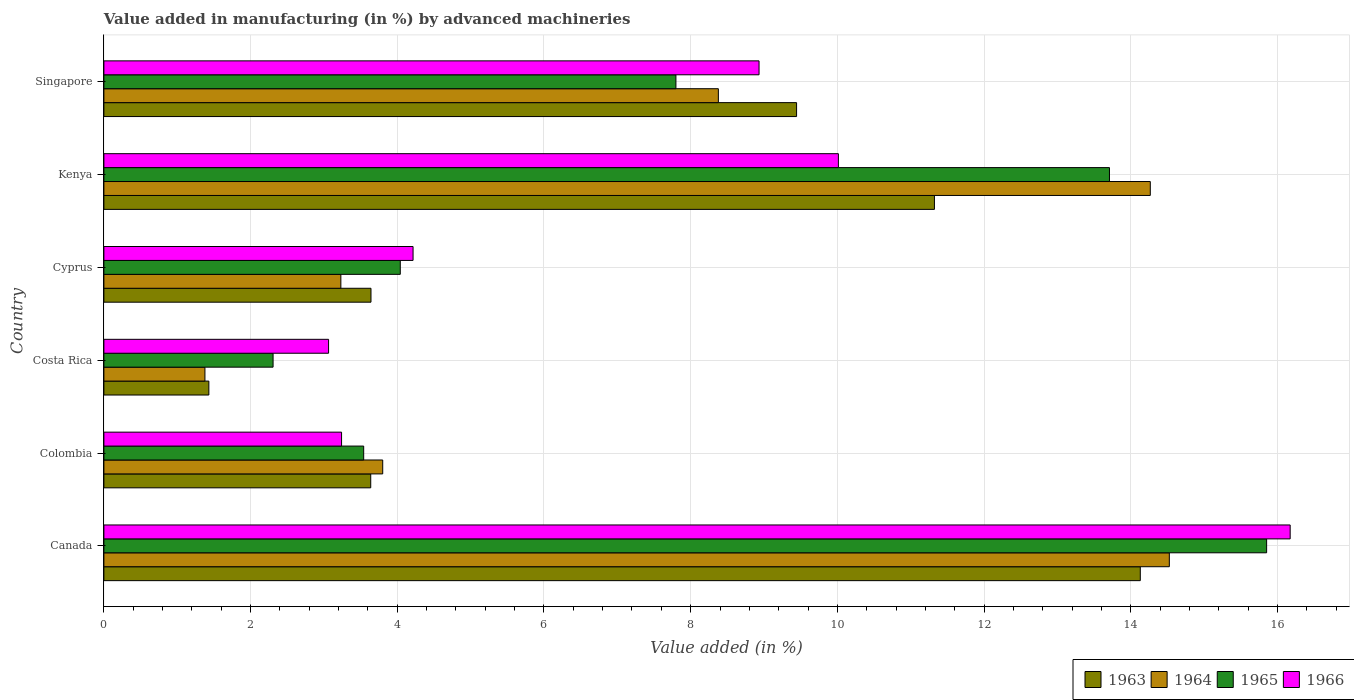How many different coloured bars are there?
Provide a succinct answer. 4. What is the percentage of value added in manufacturing by advanced machineries in 1964 in Kenya?
Offer a very short reply. 14.27. Across all countries, what is the maximum percentage of value added in manufacturing by advanced machineries in 1966?
Make the answer very short. 16.17. Across all countries, what is the minimum percentage of value added in manufacturing by advanced machineries in 1966?
Offer a very short reply. 3.06. In which country was the percentage of value added in manufacturing by advanced machineries in 1963 maximum?
Give a very brief answer. Canada. What is the total percentage of value added in manufacturing by advanced machineries in 1966 in the graph?
Your answer should be very brief. 45.64. What is the difference between the percentage of value added in manufacturing by advanced machineries in 1966 in Canada and that in Cyprus?
Give a very brief answer. 11.96. What is the difference between the percentage of value added in manufacturing by advanced machineries in 1964 in Kenya and the percentage of value added in manufacturing by advanced machineries in 1966 in Singapore?
Offer a very short reply. 5.33. What is the average percentage of value added in manufacturing by advanced machineries in 1964 per country?
Provide a short and direct response. 7.6. What is the difference between the percentage of value added in manufacturing by advanced machineries in 1964 and percentage of value added in manufacturing by advanced machineries in 1963 in Cyprus?
Provide a succinct answer. -0.41. In how many countries, is the percentage of value added in manufacturing by advanced machineries in 1965 greater than 8.4 %?
Make the answer very short. 2. What is the ratio of the percentage of value added in manufacturing by advanced machineries in 1964 in Colombia to that in Kenya?
Your answer should be compact. 0.27. Is the percentage of value added in manufacturing by advanced machineries in 1963 in Canada less than that in Kenya?
Offer a very short reply. No. Is the difference between the percentage of value added in manufacturing by advanced machineries in 1964 in Colombia and Singapore greater than the difference between the percentage of value added in manufacturing by advanced machineries in 1963 in Colombia and Singapore?
Your response must be concise. Yes. What is the difference between the highest and the second highest percentage of value added in manufacturing by advanced machineries in 1963?
Your answer should be compact. 2.81. What is the difference between the highest and the lowest percentage of value added in manufacturing by advanced machineries in 1965?
Your answer should be very brief. 13.55. In how many countries, is the percentage of value added in manufacturing by advanced machineries in 1963 greater than the average percentage of value added in manufacturing by advanced machineries in 1963 taken over all countries?
Your response must be concise. 3. Is it the case that in every country, the sum of the percentage of value added in manufacturing by advanced machineries in 1964 and percentage of value added in manufacturing by advanced machineries in 1966 is greater than the sum of percentage of value added in manufacturing by advanced machineries in 1963 and percentage of value added in manufacturing by advanced machineries in 1965?
Offer a very short reply. No. What does the 4th bar from the bottom in Canada represents?
Provide a short and direct response. 1966. Are all the bars in the graph horizontal?
Offer a very short reply. Yes. How many countries are there in the graph?
Keep it short and to the point. 6. What is the difference between two consecutive major ticks on the X-axis?
Your response must be concise. 2. Does the graph contain any zero values?
Ensure brevity in your answer.  No. Where does the legend appear in the graph?
Keep it short and to the point. Bottom right. How are the legend labels stacked?
Offer a terse response. Horizontal. What is the title of the graph?
Ensure brevity in your answer.  Value added in manufacturing (in %) by advanced machineries. What is the label or title of the X-axis?
Keep it short and to the point. Value added (in %). What is the label or title of the Y-axis?
Your answer should be very brief. Country. What is the Value added (in %) in 1963 in Canada?
Offer a terse response. 14.13. What is the Value added (in %) in 1964 in Canada?
Offer a very short reply. 14.53. What is the Value added (in %) in 1965 in Canada?
Your response must be concise. 15.85. What is the Value added (in %) of 1966 in Canada?
Offer a very short reply. 16.17. What is the Value added (in %) in 1963 in Colombia?
Make the answer very short. 3.64. What is the Value added (in %) in 1964 in Colombia?
Your answer should be compact. 3.8. What is the Value added (in %) of 1965 in Colombia?
Provide a succinct answer. 3.54. What is the Value added (in %) of 1966 in Colombia?
Provide a succinct answer. 3.24. What is the Value added (in %) in 1963 in Costa Rica?
Provide a succinct answer. 1.43. What is the Value added (in %) in 1964 in Costa Rica?
Provide a succinct answer. 1.38. What is the Value added (in %) of 1965 in Costa Rica?
Make the answer very short. 2.31. What is the Value added (in %) in 1966 in Costa Rica?
Provide a succinct answer. 3.06. What is the Value added (in %) in 1963 in Cyprus?
Your response must be concise. 3.64. What is the Value added (in %) of 1964 in Cyprus?
Offer a terse response. 3.23. What is the Value added (in %) in 1965 in Cyprus?
Offer a terse response. 4.04. What is the Value added (in %) of 1966 in Cyprus?
Keep it short and to the point. 4.22. What is the Value added (in %) in 1963 in Kenya?
Offer a very short reply. 11.32. What is the Value added (in %) of 1964 in Kenya?
Offer a very short reply. 14.27. What is the Value added (in %) in 1965 in Kenya?
Provide a short and direct response. 13.71. What is the Value added (in %) of 1966 in Kenya?
Your response must be concise. 10.01. What is the Value added (in %) of 1963 in Singapore?
Provide a short and direct response. 9.44. What is the Value added (in %) in 1964 in Singapore?
Offer a very short reply. 8.38. What is the Value added (in %) of 1965 in Singapore?
Offer a terse response. 7.8. What is the Value added (in %) in 1966 in Singapore?
Your answer should be very brief. 8.93. Across all countries, what is the maximum Value added (in %) in 1963?
Give a very brief answer. 14.13. Across all countries, what is the maximum Value added (in %) in 1964?
Make the answer very short. 14.53. Across all countries, what is the maximum Value added (in %) in 1965?
Your response must be concise. 15.85. Across all countries, what is the maximum Value added (in %) of 1966?
Your answer should be compact. 16.17. Across all countries, what is the minimum Value added (in %) in 1963?
Your answer should be compact. 1.43. Across all countries, what is the minimum Value added (in %) in 1964?
Offer a terse response. 1.38. Across all countries, what is the minimum Value added (in %) of 1965?
Ensure brevity in your answer.  2.31. Across all countries, what is the minimum Value added (in %) in 1966?
Provide a succinct answer. 3.06. What is the total Value added (in %) of 1963 in the graph?
Offer a terse response. 43.61. What is the total Value added (in %) in 1964 in the graph?
Provide a succinct answer. 45.58. What is the total Value added (in %) of 1965 in the graph?
Offer a terse response. 47.25. What is the total Value added (in %) of 1966 in the graph?
Your response must be concise. 45.64. What is the difference between the Value added (in %) in 1963 in Canada and that in Colombia?
Your answer should be very brief. 10.49. What is the difference between the Value added (in %) in 1964 in Canada and that in Colombia?
Make the answer very short. 10.72. What is the difference between the Value added (in %) of 1965 in Canada and that in Colombia?
Your answer should be compact. 12.31. What is the difference between the Value added (in %) of 1966 in Canada and that in Colombia?
Offer a very short reply. 12.93. What is the difference between the Value added (in %) in 1963 in Canada and that in Costa Rica?
Offer a very short reply. 12.7. What is the difference between the Value added (in %) in 1964 in Canada and that in Costa Rica?
Keep it short and to the point. 13.15. What is the difference between the Value added (in %) of 1965 in Canada and that in Costa Rica?
Give a very brief answer. 13.55. What is the difference between the Value added (in %) of 1966 in Canada and that in Costa Rica?
Give a very brief answer. 13.11. What is the difference between the Value added (in %) in 1963 in Canada and that in Cyprus?
Provide a succinct answer. 10.49. What is the difference between the Value added (in %) of 1964 in Canada and that in Cyprus?
Provide a short and direct response. 11.3. What is the difference between the Value added (in %) of 1965 in Canada and that in Cyprus?
Ensure brevity in your answer.  11.81. What is the difference between the Value added (in %) in 1966 in Canada and that in Cyprus?
Offer a very short reply. 11.96. What is the difference between the Value added (in %) in 1963 in Canada and that in Kenya?
Offer a very short reply. 2.81. What is the difference between the Value added (in %) in 1964 in Canada and that in Kenya?
Your answer should be very brief. 0.26. What is the difference between the Value added (in %) in 1965 in Canada and that in Kenya?
Provide a short and direct response. 2.14. What is the difference between the Value added (in %) in 1966 in Canada and that in Kenya?
Provide a succinct answer. 6.16. What is the difference between the Value added (in %) in 1963 in Canada and that in Singapore?
Keep it short and to the point. 4.69. What is the difference between the Value added (in %) of 1964 in Canada and that in Singapore?
Make the answer very short. 6.15. What is the difference between the Value added (in %) in 1965 in Canada and that in Singapore?
Offer a terse response. 8.05. What is the difference between the Value added (in %) in 1966 in Canada and that in Singapore?
Your answer should be very brief. 7.24. What is the difference between the Value added (in %) of 1963 in Colombia and that in Costa Rica?
Make the answer very short. 2.21. What is the difference between the Value added (in %) in 1964 in Colombia and that in Costa Rica?
Your response must be concise. 2.42. What is the difference between the Value added (in %) in 1965 in Colombia and that in Costa Rica?
Provide a succinct answer. 1.24. What is the difference between the Value added (in %) in 1966 in Colombia and that in Costa Rica?
Your answer should be compact. 0.18. What is the difference between the Value added (in %) in 1963 in Colombia and that in Cyprus?
Ensure brevity in your answer.  -0. What is the difference between the Value added (in %) in 1964 in Colombia and that in Cyprus?
Offer a very short reply. 0.57. What is the difference between the Value added (in %) in 1965 in Colombia and that in Cyprus?
Offer a very short reply. -0.5. What is the difference between the Value added (in %) in 1966 in Colombia and that in Cyprus?
Your answer should be very brief. -0.97. What is the difference between the Value added (in %) of 1963 in Colombia and that in Kenya?
Your response must be concise. -7.69. What is the difference between the Value added (in %) in 1964 in Colombia and that in Kenya?
Offer a terse response. -10.47. What is the difference between the Value added (in %) in 1965 in Colombia and that in Kenya?
Your response must be concise. -10.17. What is the difference between the Value added (in %) of 1966 in Colombia and that in Kenya?
Ensure brevity in your answer.  -6.77. What is the difference between the Value added (in %) of 1963 in Colombia and that in Singapore?
Make the answer very short. -5.81. What is the difference between the Value added (in %) in 1964 in Colombia and that in Singapore?
Your answer should be very brief. -4.58. What is the difference between the Value added (in %) of 1965 in Colombia and that in Singapore?
Offer a terse response. -4.26. What is the difference between the Value added (in %) in 1966 in Colombia and that in Singapore?
Provide a succinct answer. -5.69. What is the difference between the Value added (in %) in 1963 in Costa Rica and that in Cyprus?
Offer a very short reply. -2.21. What is the difference between the Value added (in %) of 1964 in Costa Rica and that in Cyprus?
Offer a very short reply. -1.85. What is the difference between the Value added (in %) of 1965 in Costa Rica and that in Cyprus?
Keep it short and to the point. -1.73. What is the difference between the Value added (in %) in 1966 in Costa Rica and that in Cyprus?
Give a very brief answer. -1.15. What is the difference between the Value added (in %) of 1963 in Costa Rica and that in Kenya?
Make the answer very short. -9.89. What is the difference between the Value added (in %) in 1964 in Costa Rica and that in Kenya?
Provide a short and direct response. -12.89. What is the difference between the Value added (in %) in 1965 in Costa Rica and that in Kenya?
Keep it short and to the point. -11.4. What is the difference between the Value added (in %) in 1966 in Costa Rica and that in Kenya?
Your answer should be compact. -6.95. What is the difference between the Value added (in %) in 1963 in Costa Rica and that in Singapore?
Your answer should be compact. -8.01. What is the difference between the Value added (in %) of 1964 in Costa Rica and that in Singapore?
Your answer should be very brief. -7. What is the difference between the Value added (in %) of 1965 in Costa Rica and that in Singapore?
Offer a terse response. -5.49. What is the difference between the Value added (in %) of 1966 in Costa Rica and that in Singapore?
Your answer should be very brief. -5.87. What is the difference between the Value added (in %) in 1963 in Cyprus and that in Kenya?
Ensure brevity in your answer.  -7.68. What is the difference between the Value added (in %) in 1964 in Cyprus and that in Kenya?
Ensure brevity in your answer.  -11.04. What is the difference between the Value added (in %) in 1965 in Cyprus and that in Kenya?
Provide a short and direct response. -9.67. What is the difference between the Value added (in %) in 1966 in Cyprus and that in Kenya?
Your answer should be very brief. -5.8. What is the difference between the Value added (in %) of 1963 in Cyprus and that in Singapore?
Give a very brief answer. -5.8. What is the difference between the Value added (in %) in 1964 in Cyprus and that in Singapore?
Your answer should be compact. -5.15. What is the difference between the Value added (in %) in 1965 in Cyprus and that in Singapore?
Your answer should be compact. -3.76. What is the difference between the Value added (in %) in 1966 in Cyprus and that in Singapore?
Your answer should be very brief. -4.72. What is the difference between the Value added (in %) of 1963 in Kenya and that in Singapore?
Your response must be concise. 1.88. What is the difference between the Value added (in %) of 1964 in Kenya and that in Singapore?
Provide a short and direct response. 5.89. What is the difference between the Value added (in %) of 1965 in Kenya and that in Singapore?
Your answer should be very brief. 5.91. What is the difference between the Value added (in %) in 1966 in Kenya and that in Singapore?
Give a very brief answer. 1.08. What is the difference between the Value added (in %) in 1963 in Canada and the Value added (in %) in 1964 in Colombia?
Your answer should be compact. 10.33. What is the difference between the Value added (in %) of 1963 in Canada and the Value added (in %) of 1965 in Colombia?
Keep it short and to the point. 10.59. What is the difference between the Value added (in %) in 1963 in Canada and the Value added (in %) in 1966 in Colombia?
Your response must be concise. 10.89. What is the difference between the Value added (in %) of 1964 in Canada and the Value added (in %) of 1965 in Colombia?
Keep it short and to the point. 10.98. What is the difference between the Value added (in %) of 1964 in Canada and the Value added (in %) of 1966 in Colombia?
Offer a very short reply. 11.29. What is the difference between the Value added (in %) of 1965 in Canada and the Value added (in %) of 1966 in Colombia?
Offer a terse response. 12.61. What is the difference between the Value added (in %) of 1963 in Canada and the Value added (in %) of 1964 in Costa Rica?
Offer a terse response. 12.75. What is the difference between the Value added (in %) of 1963 in Canada and the Value added (in %) of 1965 in Costa Rica?
Give a very brief answer. 11.82. What is the difference between the Value added (in %) of 1963 in Canada and the Value added (in %) of 1966 in Costa Rica?
Your answer should be compact. 11.07. What is the difference between the Value added (in %) in 1964 in Canada and the Value added (in %) in 1965 in Costa Rica?
Ensure brevity in your answer.  12.22. What is the difference between the Value added (in %) in 1964 in Canada and the Value added (in %) in 1966 in Costa Rica?
Keep it short and to the point. 11.46. What is the difference between the Value added (in %) of 1965 in Canada and the Value added (in %) of 1966 in Costa Rica?
Offer a very short reply. 12.79. What is the difference between the Value added (in %) in 1963 in Canada and the Value added (in %) in 1964 in Cyprus?
Your answer should be very brief. 10.9. What is the difference between the Value added (in %) in 1963 in Canada and the Value added (in %) in 1965 in Cyprus?
Provide a succinct answer. 10.09. What is the difference between the Value added (in %) in 1963 in Canada and the Value added (in %) in 1966 in Cyprus?
Your answer should be very brief. 9.92. What is the difference between the Value added (in %) of 1964 in Canada and the Value added (in %) of 1965 in Cyprus?
Give a very brief answer. 10.49. What is the difference between the Value added (in %) of 1964 in Canada and the Value added (in %) of 1966 in Cyprus?
Provide a succinct answer. 10.31. What is the difference between the Value added (in %) in 1965 in Canada and the Value added (in %) in 1966 in Cyprus?
Make the answer very short. 11.64. What is the difference between the Value added (in %) of 1963 in Canada and the Value added (in %) of 1964 in Kenya?
Provide a short and direct response. -0.14. What is the difference between the Value added (in %) in 1963 in Canada and the Value added (in %) in 1965 in Kenya?
Provide a short and direct response. 0.42. What is the difference between the Value added (in %) in 1963 in Canada and the Value added (in %) in 1966 in Kenya?
Give a very brief answer. 4.12. What is the difference between the Value added (in %) in 1964 in Canada and the Value added (in %) in 1965 in Kenya?
Your answer should be very brief. 0.82. What is the difference between the Value added (in %) in 1964 in Canada and the Value added (in %) in 1966 in Kenya?
Your answer should be compact. 4.51. What is the difference between the Value added (in %) in 1965 in Canada and the Value added (in %) in 1966 in Kenya?
Your response must be concise. 5.84. What is the difference between the Value added (in %) of 1963 in Canada and the Value added (in %) of 1964 in Singapore?
Provide a succinct answer. 5.75. What is the difference between the Value added (in %) of 1963 in Canada and the Value added (in %) of 1965 in Singapore?
Ensure brevity in your answer.  6.33. What is the difference between the Value added (in %) in 1963 in Canada and the Value added (in %) in 1966 in Singapore?
Ensure brevity in your answer.  5.2. What is the difference between the Value added (in %) in 1964 in Canada and the Value added (in %) in 1965 in Singapore?
Ensure brevity in your answer.  6.73. What is the difference between the Value added (in %) of 1964 in Canada and the Value added (in %) of 1966 in Singapore?
Offer a very short reply. 5.59. What is the difference between the Value added (in %) of 1965 in Canada and the Value added (in %) of 1966 in Singapore?
Make the answer very short. 6.92. What is the difference between the Value added (in %) in 1963 in Colombia and the Value added (in %) in 1964 in Costa Rica?
Offer a very short reply. 2.26. What is the difference between the Value added (in %) of 1963 in Colombia and the Value added (in %) of 1965 in Costa Rica?
Offer a terse response. 1.33. What is the difference between the Value added (in %) of 1963 in Colombia and the Value added (in %) of 1966 in Costa Rica?
Your response must be concise. 0.57. What is the difference between the Value added (in %) in 1964 in Colombia and the Value added (in %) in 1965 in Costa Rica?
Provide a succinct answer. 1.49. What is the difference between the Value added (in %) in 1964 in Colombia and the Value added (in %) in 1966 in Costa Rica?
Ensure brevity in your answer.  0.74. What is the difference between the Value added (in %) of 1965 in Colombia and the Value added (in %) of 1966 in Costa Rica?
Provide a short and direct response. 0.48. What is the difference between the Value added (in %) of 1963 in Colombia and the Value added (in %) of 1964 in Cyprus?
Your answer should be very brief. 0.41. What is the difference between the Value added (in %) in 1963 in Colombia and the Value added (in %) in 1965 in Cyprus?
Your answer should be very brief. -0.4. What is the difference between the Value added (in %) in 1963 in Colombia and the Value added (in %) in 1966 in Cyprus?
Offer a terse response. -0.58. What is the difference between the Value added (in %) in 1964 in Colombia and the Value added (in %) in 1965 in Cyprus?
Ensure brevity in your answer.  -0.24. What is the difference between the Value added (in %) of 1964 in Colombia and the Value added (in %) of 1966 in Cyprus?
Give a very brief answer. -0.41. What is the difference between the Value added (in %) of 1965 in Colombia and the Value added (in %) of 1966 in Cyprus?
Ensure brevity in your answer.  -0.67. What is the difference between the Value added (in %) in 1963 in Colombia and the Value added (in %) in 1964 in Kenya?
Offer a very short reply. -10.63. What is the difference between the Value added (in %) in 1963 in Colombia and the Value added (in %) in 1965 in Kenya?
Offer a terse response. -10.07. What is the difference between the Value added (in %) in 1963 in Colombia and the Value added (in %) in 1966 in Kenya?
Offer a very short reply. -6.38. What is the difference between the Value added (in %) in 1964 in Colombia and the Value added (in %) in 1965 in Kenya?
Offer a very short reply. -9.91. What is the difference between the Value added (in %) in 1964 in Colombia and the Value added (in %) in 1966 in Kenya?
Provide a succinct answer. -6.21. What is the difference between the Value added (in %) in 1965 in Colombia and the Value added (in %) in 1966 in Kenya?
Ensure brevity in your answer.  -6.47. What is the difference between the Value added (in %) in 1963 in Colombia and the Value added (in %) in 1964 in Singapore?
Keep it short and to the point. -4.74. What is the difference between the Value added (in %) in 1963 in Colombia and the Value added (in %) in 1965 in Singapore?
Your answer should be very brief. -4.16. What is the difference between the Value added (in %) in 1963 in Colombia and the Value added (in %) in 1966 in Singapore?
Offer a terse response. -5.29. What is the difference between the Value added (in %) in 1964 in Colombia and the Value added (in %) in 1965 in Singapore?
Your answer should be compact. -4. What is the difference between the Value added (in %) in 1964 in Colombia and the Value added (in %) in 1966 in Singapore?
Ensure brevity in your answer.  -5.13. What is the difference between the Value added (in %) in 1965 in Colombia and the Value added (in %) in 1966 in Singapore?
Ensure brevity in your answer.  -5.39. What is the difference between the Value added (in %) in 1963 in Costa Rica and the Value added (in %) in 1964 in Cyprus?
Keep it short and to the point. -1.8. What is the difference between the Value added (in %) of 1963 in Costa Rica and the Value added (in %) of 1965 in Cyprus?
Your response must be concise. -2.61. What is the difference between the Value added (in %) in 1963 in Costa Rica and the Value added (in %) in 1966 in Cyprus?
Provide a succinct answer. -2.78. What is the difference between the Value added (in %) of 1964 in Costa Rica and the Value added (in %) of 1965 in Cyprus?
Make the answer very short. -2.66. What is the difference between the Value added (in %) in 1964 in Costa Rica and the Value added (in %) in 1966 in Cyprus?
Offer a very short reply. -2.84. What is the difference between the Value added (in %) of 1965 in Costa Rica and the Value added (in %) of 1966 in Cyprus?
Provide a short and direct response. -1.91. What is the difference between the Value added (in %) of 1963 in Costa Rica and the Value added (in %) of 1964 in Kenya?
Make the answer very short. -12.84. What is the difference between the Value added (in %) in 1963 in Costa Rica and the Value added (in %) in 1965 in Kenya?
Provide a short and direct response. -12.28. What is the difference between the Value added (in %) of 1963 in Costa Rica and the Value added (in %) of 1966 in Kenya?
Your response must be concise. -8.58. What is the difference between the Value added (in %) of 1964 in Costa Rica and the Value added (in %) of 1965 in Kenya?
Your answer should be very brief. -12.33. What is the difference between the Value added (in %) in 1964 in Costa Rica and the Value added (in %) in 1966 in Kenya?
Offer a terse response. -8.64. What is the difference between the Value added (in %) of 1965 in Costa Rica and the Value added (in %) of 1966 in Kenya?
Your answer should be very brief. -7.71. What is the difference between the Value added (in %) of 1963 in Costa Rica and the Value added (in %) of 1964 in Singapore?
Your answer should be compact. -6.95. What is the difference between the Value added (in %) in 1963 in Costa Rica and the Value added (in %) in 1965 in Singapore?
Offer a terse response. -6.37. What is the difference between the Value added (in %) of 1963 in Costa Rica and the Value added (in %) of 1966 in Singapore?
Keep it short and to the point. -7.5. What is the difference between the Value added (in %) in 1964 in Costa Rica and the Value added (in %) in 1965 in Singapore?
Ensure brevity in your answer.  -6.42. What is the difference between the Value added (in %) in 1964 in Costa Rica and the Value added (in %) in 1966 in Singapore?
Your answer should be compact. -7.55. What is the difference between the Value added (in %) in 1965 in Costa Rica and the Value added (in %) in 1966 in Singapore?
Keep it short and to the point. -6.63. What is the difference between the Value added (in %) of 1963 in Cyprus and the Value added (in %) of 1964 in Kenya?
Provide a short and direct response. -10.63. What is the difference between the Value added (in %) of 1963 in Cyprus and the Value added (in %) of 1965 in Kenya?
Offer a very short reply. -10.07. What is the difference between the Value added (in %) in 1963 in Cyprus and the Value added (in %) in 1966 in Kenya?
Your answer should be compact. -6.37. What is the difference between the Value added (in %) in 1964 in Cyprus and the Value added (in %) in 1965 in Kenya?
Offer a terse response. -10.48. What is the difference between the Value added (in %) of 1964 in Cyprus and the Value added (in %) of 1966 in Kenya?
Make the answer very short. -6.78. What is the difference between the Value added (in %) in 1965 in Cyprus and the Value added (in %) in 1966 in Kenya?
Your response must be concise. -5.97. What is the difference between the Value added (in %) of 1963 in Cyprus and the Value added (in %) of 1964 in Singapore?
Your response must be concise. -4.74. What is the difference between the Value added (in %) of 1963 in Cyprus and the Value added (in %) of 1965 in Singapore?
Your response must be concise. -4.16. What is the difference between the Value added (in %) of 1963 in Cyprus and the Value added (in %) of 1966 in Singapore?
Ensure brevity in your answer.  -5.29. What is the difference between the Value added (in %) in 1964 in Cyprus and the Value added (in %) in 1965 in Singapore?
Your answer should be very brief. -4.57. What is the difference between the Value added (in %) in 1964 in Cyprus and the Value added (in %) in 1966 in Singapore?
Make the answer very short. -5.7. What is the difference between the Value added (in %) in 1965 in Cyprus and the Value added (in %) in 1966 in Singapore?
Offer a very short reply. -4.89. What is the difference between the Value added (in %) in 1963 in Kenya and the Value added (in %) in 1964 in Singapore?
Give a very brief answer. 2.95. What is the difference between the Value added (in %) in 1963 in Kenya and the Value added (in %) in 1965 in Singapore?
Give a very brief answer. 3.52. What is the difference between the Value added (in %) in 1963 in Kenya and the Value added (in %) in 1966 in Singapore?
Ensure brevity in your answer.  2.39. What is the difference between the Value added (in %) in 1964 in Kenya and the Value added (in %) in 1965 in Singapore?
Your answer should be compact. 6.47. What is the difference between the Value added (in %) in 1964 in Kenya and the Value added (in %) in 1966 in Singapore?
Your answer should be compact. 5.33. What is the difference between the Value added (in %) in 1965 in Kenya and the Value added (in %) in 1966 in Singapore?
Provide a short and direct response. 4.78. What is the average Value added (in %) of 1963 per country?
Keep it short and to the point. 7.27. What is the average Value added (in %) in 1964 per country?
Make the answer very short. 7.6. What is the average Value added (in %) in 1965 per country?
Offer a terse response. 7.88. What is the average Value added (in %) in 1966 per country?
Make the answer very short. 7.61. What is the difference between the Value added (in %) of 1963 and Value added (in %) of 1964 in Canada?
Provide a succinct answer. -0.4. What is the difference between the Value added (in %) of 1963 and Value added (in %) of 1965 in Canada?
Your answer should be very brief. -1.72. What is the difference between the Value added (in %) in 1963 and Value added (in %) in 1966 in Canada?
Keep it short and to the point. -2.04. What is the difference between the Value added (in %) in 1964 and Value added (in %) in 1965 in Canada?
Your answer should be very brief. -1.33. What is the difference between the Value added (in %) of 1964 and Value added (in %) of 1966 in Canada?
Give a very brief answer. -1.65. What is the difference between the Value added (in %) in 1965 and Value added (in %) in 1966 in Canada?
Provide a short and direct response. -0.32. What is the difference between the Value added (in %) in 1963 and Value added (in %) in 1964 in Colombia?
Keep it short and to the point. -0.16. What is the difference between the Value added (in %) in 1963 and Value added (in %) in 1965 in Colombia?
Make the answer very short. 0.1. What is the difference between the Value added (in %) in 1963 and Value added (in %) in 1966 in Colombia?
Provide a short and direct response. 0.4. What is the difference between the Value added (in %) in 1964 and Value added (in %) in 1965 in Colombia?
Make the answer very short. 0.26. What is the difference between the Value added (in %) in 1964 and Value added (in %) in 1966 in Colombia?
Your response must be concise. 0.56. What is the difference between the Value added (in %) of 1965 and Value added (in %) of 1966 in Colombia?
Give a very brief answer. 0.3. What is the difference between the Value added (in %) of 1963 and Value added (in %) of 1964 in Costa Rica?
Provide a short and direct response. 0.05. What is the difference between the Value added (in %) in 1963 and Value added (in %) in 1965 in Costa Rica?
Provide a succinct answer. -0.88. What is the difference between the Value added (in %) of 1963 and Value added (in %) of 1966 in Costa Rica?
Offer a terse response. -1.63. What is the difference between the Value added (in %) in 1964 and Value added (in %) in 1965 in Costa Rica?
Your answer should be compact. -0.93. What is the difference between the Value added (in %) of 1964 and Value added (in %) of 1966 in Costa Rica?
Your response must be concise. -1.69. What is the difference between the Value added (in %) of 1965 and Value added (in %) of 1966 in Costa Rica?
Provide a short and direct response. -0.76. What is the difference between the Value added (in %) of 1963 and Value added (in %) of 1964 in Cyprus?
Offer a very short reply. 0.41. What is the difference between the Value added (in %) in 1963 and Value added (in %) in 1965 in Cyprus?
Your answer should be compact. -0.4. What is the difference between the Value added (in %) in 1963 and Value added (in %) in 1966 in Cyprus?
Make the answer very short. -0.57. What is the difference between the Value added (in %) in 1964 and Value added (in %) in 1965 in Cyprus?
Give a very brief answer. -0.81. What is the difference between the Value added (in %) of 1964 and Value added (in %) of 1966 in Cyprus?
Offer a very short reply. -0.98. What is the difference between the Value added (in %) of 1965 and Value added (in %) of 1966 in Cyprus?
Your answer should be very brief. -0.17. What is the difference between the Value added (in %) in 1963 and Value added (in %) in 1964 in Kenya?
Offer a terse response. -2.94. What is the difference between the Value added (in %) of 1963 and Value added (in %) of 1965 in Kenya?
Your response must be concise. -2.39. What is the difference between the Value added (in %) in 1963 and Value added (in %) in 1966 in Kenya?
Ensure brevity in your answer.  1.31. What is the difference between the Value added (in %) of 1964 and Value added (in %) of 1965 in Kenya?
Provide a short and direct response. 0.56. What is the difference between the Value added (in %) of 1964 and Value added (in %) of 1966 in Kenya?
Offer a terse response. 4.25. What is the difference between the Value added (in %) of 1965 and Value added (in %) of 1966 in Kenya?
Your answer should be compact. 3.7. What is the difference between the Value added (in %) in 1963 and Value added (in %) in 1964 in Singapore?
Ensure brevity in your answer.  1.07. What is the difference between the Value added (in %) of 1963 and Value added (in %) of 1965 in Singapore?
Your response must be concise. 1.64. What is the difference between the Value added (in %) of 1963 and Value added (in %) of 1966 in Singapore?
Provide a short and direct response. 0.51. What is the difference between the Value added (in %) of 1964 and Value added (in %) of 1965 in Singapore?
Offer a very short reply. 0.58. What is the difference between the Value added (in %) of 1964 and Value added (in %) of 1966 in Singapore?
Offer a terse response. -0.55. What is the difference between the Value added (in %) of 1965 and Value added (in %) of 1966 in Singapore?
Give a very brief answer. -1.13. What is the ratio of the Value added (in %) of 1963 in Canada to that in Colombia?
Keep it short and to the point. 3.88. What is the ratio of the Value added (in %) in 1964 in Canada to that in Colombia?
Keep it short and to the point. 3.82. What is the ratio of the Value added (in %) of 1965 in Canada to that in Colombia?
Keep it short and to the point. 4.48. What is the ratio of the Value added (in %) of 1966 in Canada to that in Colombia?
Your response must be concise. 4.99. What is the ratio of the Value added (in %) of 1963 in Canada to that in Costa Rica?
Ensure brevity in your answer.  9.87. What is the ratio of the Value added (in %) in 1964 in Canada to that in Costa Rica?
Provide a short and direct response. 10.54. What is the ratio of the Value added (in %) in 1965 in Canada to that in Costa Rica?
Offer a terse response. 6.87. What is the ratio of the Value added (in %) in 1966 in Canada to that in Costa Rica?
Provide a succinct answer. 5.28. What is the ratio of the Value added (in %) in 1963 in Canada to that in Cyprus?
Offer a very short reply. 3.88. What is the ratio of the Value added (in %) of 1964 in Canada to that in Cyprus?
Your response must be concise. 4.5. What is the ratio of the Value added (in %) of 1965 in Canada to that in Cyprus?
Ensure brevity in your answer.  3.92. What is the ratio of the Value added (in %) of 1966 in Canada to that in Cyprus?
Offer a terse response. 3.84. What is the ratio of the Value added (in %) in 1963 in Canada to that in Kenya?
Keep it short and to the point. 1.25. What is the ratio of the Value added (in %) of 1964 in Canada to that in Kenya?
Your response must be concise. 1.02. What is the ratio of the Value added (in %) in 1965 in Canada to that in Kenya?
Ensure brevity in your answer.  1.16. What is the ratio of the Value added (in %) of 1966 in Canada to that in Kenya?
Offer a very short reply. 1.62. What is the ratio of the Value added (in %) of 1963 in Canada to that in Singapore?
Provide a short and direct response. 1.5. What is the ratio of the Value added (in %) in 1964 in Canada to that in Singapore?
Offer a terse response. 1.73. What is the ratio of the Value added (in %) in 1965 in Canada to that in Singapore?
Your answer should be compact. 2.03. What is the ratio of the Value added (in %) in 1966 in Canada to that in Singapore?
Offer a very short reply. 1.81. What is the ratio of the Value added (in %) of 1963 in Colombia to that in Costa Rica?
Your response must be concise. 2.54. What is the ratio of the Value added (in %) of 1964 in Colombia to that in Costa Rica?
Your response must be concise. 2.76. What is the ratio of the Value added (in %) of 1965 in Colombia to that in Costa Rica?
Your response must be concise. 1.54. What is the ratio of the Value added (in %) of 1966 in Colombia to that in Costa Rica?
Your answer should be very brief. 1.06. What is the ratio of the Value added (in %) in 1964 in Colombia to that in Cyprus?
Make the answer very short. 1.18. What is the ratio of the Value added (in %) in 1965 in Colombia to that in Cyprus?
Provide a short and direct response. 0.88. What is the ratio of the Value added (in %) of 1966 in Colombia to that in Cyprus?
Make the answer very short. 0.77. What is the ratio of the Value added (in %) in 1963 in Colombia to that in Kenya?
Keep it short and to the point. 0.32. What is the ratio of the Value added (in %) in 1964 in Colombia to that in Kenya?
Your answer should be compact. 0.27. What is the ratio of the Value added (in %) of 1965 in Colombia to that in Kenya?
Your answer should be very brief. 0.26. What is the ratio of the Value added (in %) in 1966 in Colombia to that in Kenya?
Offer a very short reply. 0.32. What is the ratio of the Value added (in %) in 1963 in Colombia to that in Singapore?
Make the answer very short. 0.39. What is the ratio of the Value added (in %) in 1964 in Colombia to that in Singapore?
Ensure brevity in your answer.  0.45. What is the ratio of the Value added (in %) in 1965 in Colombia to that in Singapore?
Offer a terse response. 0.45. What is the ratio of the Value added (in %) of 1966 in Colombia to that in Singapore?
Ensure brevity in your answer.  0.36. What is the ratio of the Value added (in %) of 1963 in Costa Rica to that in Cyprus?
Provide a short and direct response. 0.39. What is the ratio of the Value added (in %) of 1964 in Costa Rica to that in Cyprus?
Keep it short and to the point. 0.43. What is the ratio of the Value added (in %) in 1965 in Costa Rica to that in Cyprus?
Your response must be concise. 0.57. What is the ratio of the Value added (in %) of 1966 in Costa Rica to that in Cyprus?
Keep it short and to the point. 0.73. What is the ratio of the Value added (in %) in 1963 in Costa Rica to that in Kenya?
Keep it short and to the point. 0.13. What is the ratio of the Value added (in %) in 1964 in Costa Rica to that in Kenya?
Provide a short and direct response. 0.1. What is the ratio of the Value added (in %) of 1965 in Costa Rica to that in Kenya?
Give a very brief answer. 0.17. What is the ratio of the Value added (in %) in 1966 in Costa Rica to that in Kenya?
Your response must be concise. 0.31. What is the ratio of the Value added (in %) in 1963 in Costa Rica to that in Singapore?
Provide a succinct answer. 0.15. What is the ratio of the Value added (in %) in 1964 in Costa Rica to that in Singapore?
Give a very brief answer. 0.16. What is the ratio of the Value added (in %) of 1965 in Costa Rica to that in Singapore?
Offer a very short reply. 0.3. What is the ratio of the Value added (in %) in 1966 in Costa Rica to that in Singapore?
Give a very brief answer. 0.34. What is the ratio of the Value added (in %) of 1963 in Cyprus to that in Kenya?
Your response must be concise. 0.32. What is the ratio of the Value added (in %) in 1964 in Cyprus to that in Kenya?
Ensure brevity in your answer.  0.23. What is the ratio of the Value added (in %) in 1965 in Cyprus to that in Kenya?
Ensure brevity in your answer.  0.29. What is the ratio of the Value added (in %) of 1966 in Cyprus to that in Kenya?
Ensure brevity in your answer.  0.42. What is the ratio of the Value added (in %) of 1963 in Cyprus to that in Singapore?
Offer a very short reply. 0.39. What is the ratio of the Value added (in %) in 1964 in Cyprus to that in Singapore?
Your answer should be compact. 0.39. What is the ratio of the Value added (in %) in 1965 in Cyprus to that in Singapore?
Your answer should be very brief. 0.52. What is the ratio of the Value added (in %) of 1966 in Cyprus to that in Singapore?
Your answer should be compact. 0.47. What is the ratio of the Value added (in %) in 1963 in Kenya to that in Singapore?
Offer a very short reply. 1.2. What is the ratio of the Value added (in %) in 1964 in Kenya to that in Singapore?
Your response must be concise. 1.7. What is the ratio of the Value added (in %) in 1965 in Kenya to that in Singapore?
Keep it short and to the point. 1.76. What is the ratio of the Value added (in %) of 1966 in Kenya to that in Singapore?
Your answer should be compact. 1.12. What is the difference between the highest and the second highest Value added (in %) of 1963?
Keep it short and to the point. 2.81. What is the difference between the highest and the second highest Value added (in %) in 1964?
Your answer should be compact. 0.26. What is the difference between the highest and the second highest Value added (in %) of 1965?
Keep it short and to the point. 2.14. What is the difference between the highest and the second highest Value added (in %) in 1966?
Your answer should be very brief. 6.16. What is the difference between the highest and the lowest Value added (in %) of 1963?
Keep it short and to the point. 12.7. What is the difference between the highest and the lowest Value added (in %) of 1964?
Provide a succinct answer. 13.15. What is the difference between the highest and the lowest Value added (in %) of 1965?
Provide a short and direct response. 13.55. What is the difference between the highest and the lowest Value added (in %) in 1966?
Offer a very short reply. 13.11. 